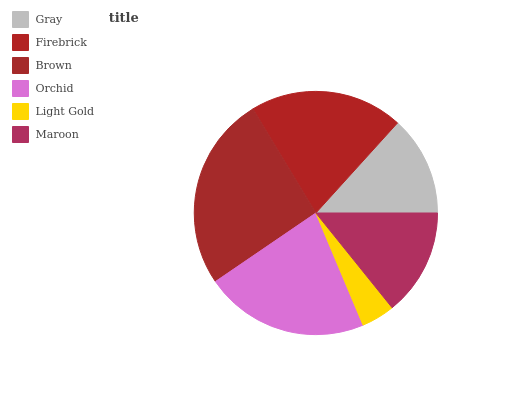Is Light Gold the minimum?
Answer yes or no. Yes. Is Brown the maximum?
Answer yes or no. Yes. Is Firebrick the minimum?
Answer yes or no. No. Is Firebrick the maximum?
Answer yes or no. No. Is Firebrick greater than Gray?
Answer yes or no. Yes. Is Gray less than Firebrick?
Answer yes or no. Yes. Is Gray greater than Firebrick?
Answer yes or no. No. Is Firebrick less than Gray?
Answer yes or no. No. Is Firebrick the high median?
Answer yes or no. Yes. Is Maroon the low median?
Answer yes or no. Yes. Is Gray the high median?
Answer yes or no. No. Is Brown the low median?
Answer yes or no. No. 